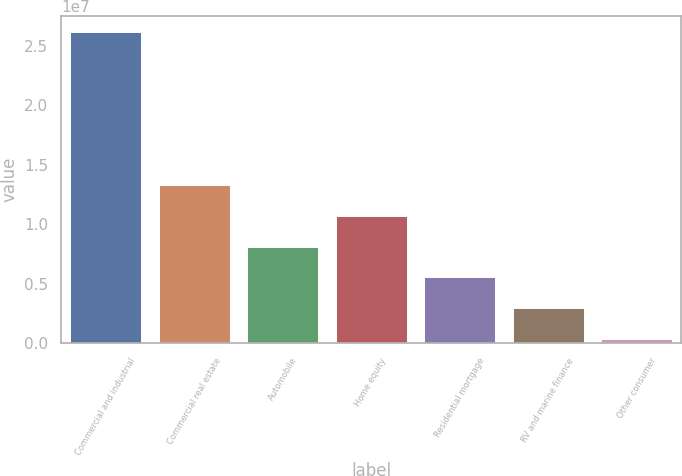Convert chart. <chart><loc_0><loc_0><loc_500><loc_500><bar_chart><fcel>Commercial and industrial<fcel>Commercial real estate<fcel>Automobile<fcel>Home equity<fcel>Residential mortgage<fcel>RV and marine finance<fcel>Other consumer<nl><fcel>2.62119e+07<fcel>1.32794e+07<fcel>8.10637e+06<fcel>1.06929e+07<fcel>5.51987e+06<fcel>2.93337e+06<fcel>346867<nl></chart> 